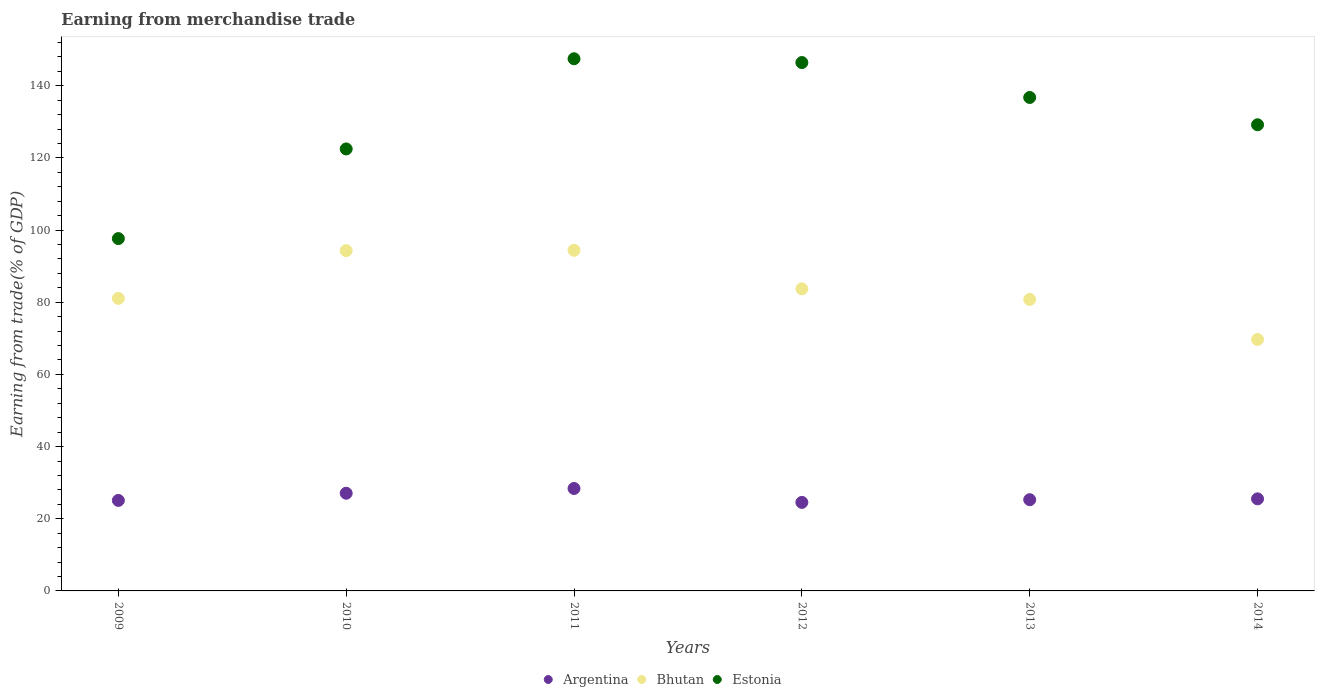How many different coloured dotlines are there?
Your answer should be compact. 3. What is the earnings from trade in Bhutan in 2012?
Ensure brevity in your answer.  83.71. Across all years, what is the maximum earnings from trade in Argentina?
Your answer should be very brief. 28.39. Across all years, what is the minimum earnings from trade in Argentina?
Keep it short and to the point. 24.53. In which year was the earnings from trade in Bhutan maximum?
Give a very brief answer. 2011. In which year was the earnings from trade in Argentina minimum?
Offer a very short reply. 2012. What is the total earnings from trade in Estonia in the graph?
Offer a terse response. 779.94. What is the difference between the earnings from trade in Bhutan in 2010 and that in 2014?
Ensure brevity in your answer.  24.62. What is the difference between the earnings from trade in Estonia in 2012 and the earnings from trade in Argentina in 2009?
Offer a terse response. 121.34. What is the average earnings from trade in Estonia per year?
Your answer should be very brief. 129.99. In the year 2014, what is the difference between the earnings from trade in Estonia and earnings from trade in Bhutan?
Provide a short and direct response. 59.5. In how many years, is the earnings from trade in Bhutan greater than 40 %?
Ensure brevity in your answer.  6. What is the ratio of the earnings from trade in Argentina in 2009 to that in 2013?
Your response must be concise. 0.99. Is the earnings from trade in Argentina in 2011 less than that in 2012?
Provide a short and direct response. No. What is the difference between the highest and the second highest earnings from trade in Estonia?
Provide a succinct answer. 1.05. What is the difference between the highest and the lowest earnings from trade in Bhutan?
Ensure brevity in your answer.  24.7. Is the sum of the earnings from trade in Bhutan in 2010 and 2012 greater than the maximum earnings from trade in Estonia across all years?
Give a very brief answer. Yes. What is the difference between two consecutive major ticks on the Y-axis?
Offer a very short reply. 20. Where does the legend appear in the graph?
Offer a terse response. Bottom center. How are the legend labels stacked?
Provide a short and direct response. Horizontal. What is the title of the graph?
Make the answer very short. Earning from merchandise trade. What is the label or title of the X-axis?
Make the answer very short. Years. What is the label or title of the Y-axis?
Give a very brief answer. Earning from trade(% of GDP). What is the Earning from trade(% of GDP) of Argentina in 2009?
Your answer should be compact. 25.08. What is the Earning from trade(% of GDP) in Bhutan in 2009?
Provide a succinct answer. 81.06. What is the Earning from trade(% of GDP) in Estonia in 2009?
Give a very brief answer. 97.64. What is the Earning from trade(% of GDP) of Argentina in 2010?
Offer a very short reply. 27.07. What is the Earning from trade(% of GDP) of Bhutan in 2010?
Your answer should be compact. 94.3. What is the Earning from trade(% of GDP) in Estonia in 2010?
Your answer should be very brief. 122.48. What is the Earning from trade(% of GDP) in Argentina in 2011?
Keep it short and to the point. 28.39. What is the Earning from trade(% of GDP) of Bhutan in 2011?
Your answer should be compact. 94.39. What is the Earning from trade(% of GDP) of Estonia in 2011?
Provide a succinct answer. 147.47. What is the Earning from trade(% of GDP) in Argentina in 2012?
Give a very brief answer. 24.53. What is the Earning from trade(% of GDP) of Bhutan in 2012?
Keep it short and to the point. 83.71. What is the Earning from trade(% of GDP) of Estonia in 2012?
Your answer should be compact. 146.42. What is the Earning from trade(% of GDP) in Argentina in 2013?
Give a very brief answer. 25.28. What is the Earning from trade(% of GDP) of Bhutan in 2013?
Keep it short and to the point. 80.78. What is the Earning from trade(% of GDP) in Estonia in 2013?
Provide a succinct answer. 136.74. What is the Earning from trade(% of GDP) in Argentina in 2014?
Your response must be concise. 25.52. What is the Earning from trade(% of GDP) of Bhutan in 2014?
Provide a succinct answer. 69.69. What is the Earning from trade(% of GDP) of Estonia in 2014?
Your answer should be very brief. 129.18. Across all years, what is the maximum Earning from trade(% of GDP) in Argentina?
Provide a succinct answer. 28.39. Across all years, what is the maximum Earning from trade(% of GDP) in Bhutan?
Offer a very short reply. 94.39. Across all years, what is the maximum Earning from trade(% of GDP) in Estonia?
Offer a terse response. 147.47. Across all years, what is the minimum Earning from trade(% of GDP) of Argentina?
Provide a succinct answer. 24.53. Across all years, what is the minimum Earning from trade(% of GDP) in Bhutan?
Offer a terse response. 69.69. Across all years, what is the minimum Earning from trade(% of GDP) in Estonia?
Your response must be concise. 97.64. What is the total Earning from trade(% of GDP) of Argentina in the graph?
Keep it short and to the point. 155.87. What is the total Earning from trade(% of GDP) in Bhutan in the graph?
Keep it short and to the point. 503.93. What is the total Earning from trade(% of GDP) of Estonia in the graph?
Provide a succinct answer. 779.94. What is the difference between the Earning from trade(% of GDP) of Argentina in 2009 and that in 2010?
Provide a short and direct response. -1.99. What is the difference between the Earning from trade(% of GDP) of Bhutan in 2009 and that in 2010?
Your answer should be compact. -13.24. What is the difference between the Earning from trade(% of GDP) in Estonia in 2009 and that in 2010?
Provide a succinct answer. -24.85. What is the difference between the Earning from trade(% of GDP) in Argentina in 2009 and that in 2011?
Give a very brief answer. -3.31. What is the difference between the Earning from trade(% of GDP) of Bhutan in 2009 and that in 2011?
Offer a terse response. -13.33. What is the difference between the Earning from trade(% of GDP) in Estonia in 2009 and that in 2011?
Provide a short and direct response. -49.84. What is the difference between the Earning from trade(% of GDP) in Argentina in 2009 and that in 2012?
Make the answer very short. 0.55. What is the difference between the Earning from trade(% of GDP) in Bhutan in 2009 and that in 2012?
Provide a short and direct response. -2.65. What is the difference between the Earning from trade(% of GDP) of Estonia in 2009 and that in 2012?
Ensure brevity in your answer.  -48.78. What is the difference between the Earning from trade(% of GDP) of Bhutan in 2009 and that in 2013?
Your answer should be compact. 0.28. What is the difference between the Earning from trade(% of GDP) in Estonia in 2009 and that in 2013?
Your response must be concise. -39.11. What is the difference between the Earning from trade(% of GDP) of Argentina in 2009 and that in 2014?
Keep it short and to the point. -0.44. What is the difference between the Earning from trade(% of GDP) in Bhutan in 2009 and that in 2014?
Ensure brevity in your answer.  11.38. What is the difference between the Earning from trade(% of GDP) of Estonia in 2009 and that in 2014?
Your answer should be very brief. -31.54. What is the difference between the Earning from trade(% of GDP) in Argentina in 2010 and that in 2011?
Your answer should be compact. -1.31. What is the difference between the Earning from trade(% of GDP) of Bhutan in 2010 and that in 2011?
Make the answer very short. -0.09. What is the difference between the Earning from trade(% of GDP) in Estonia in 2010 and that in 2011?
Provide a succinct answer. -24.99. What is the difference between the Earning from trade(% of GDP) in Argentina in 2010 and that in 2012?
Ensure brevity in your answer.  2.54. What is the difference between the Earning from trade(% of GDP) in Bhutan in 2010 and that in 2012?
Offer a terse response. 10.59. What is the difference between the Earning from trade(% of GDP) in Estonia in 2010 and that in 2012?
Provide a short and direct response. -23.94. What is the difference between the Earning from trade(% of GDP) of Argentina in 2010 and that in 2013?
Your response must be concise. 1.79. What is the difference between the Earning from trade(% of GDP) of Bhutan in 2010 and that in 2013?
Keep it short and to the point. 13.52. What is the difference between the Earning from trade(% of GDP) of Estonia in 2010 and that in 2013?
Your answer should be very brief. -14.26. What is the difference between the Earning from trade(% of GDP) of Argentina in 2010 and that in 2014?
Offer a very short reply. 1.56. What is the difference between the Earning from trade(% of GDP) in Bhutan in 2010 and that in 2014?
Make the answer very short. 24.62. What is the difference between the Earning from trade(% of GDP) of Estonia in 2010 and that in 2014?
Offer a very short reply. -6.7. What is the difference between the Earning from trade(% of GDP) in Argentina in 2011 and that in 2012?
Provide a short and direct response. 3.86. What is the difference between the Earning from trade(% of GDP) in Bhutan in 2011 and that in 2012?
Your answer should be compact. 10.68. What is the difference between the Earning from trade(% of GDP) in Estonia in 2011 and that in 2012?
Ensure brevity in your answer.  1.05. What is the difference between the Earning from trade(% of GDP) in Argentina in 2011 and that in 2013?
Ensure brevity in your answer.  3.11. What is the difference between the Earning from trade(% of GDP) in Bhutan in 2011 and that in 2013?
Give a very brief answer. 13.61. What is the difference between the Earning from trade(% of GDP) in Estonia in 2011 and that in 2013?
Give a very brief answer. 10.73. What is the difference between the Earning from trade(% of GDP) in Argentina in 2011 and that in 2014?
Ensure brevity in your answer.  2.87. What is the difference between the Earning from trade(% of GDP) of Bhutan in 2011 and that in 2014?
Ensure brevity in your answer.  24.7. What is the difference between the Earning from trade(% of GDP) of Estonia in 2011 and that in 2014?
Your response must be concise. 18.29. What is the difference between the Earning from trade(% of GDP) in Argentina in 2012 and that in 2013?
Keep it short and to the point. -0.75. What is the difference between the Earning from trade(% of GDP) of Bhutan in 2012 and that in 2013?
Ensure brevity in your answer.  2.93. What is the difference between the Earning from trade(% of GDP) in Estonia in 2012 and that in 2013?
Keep it short and to the point. 9.68. What is the difference between the Earning from trade(% of GDP) in Argentina in 2012 and that in 2014?
Offer a very short reply. -0.98. What is the difference between the Earning from trade(% of GDP) in Bhutan in 2012 and that in 2014?
Provide a short and direct response. 14.02. What is the difference between the Earning from trade(% of GDP) in Estonia in 2012 and that in 2014?
Your answer should be compact. 17.24. What is the difference between the Earning from trade(% of GDP) of Argentina in 2013 and that in 2014?
Keep it short and to the point. -0.24. What is the difference between the Earning from trade(% of GDP) in Bhutan in 2013 and that in 2014?
Ensure brevity in your answer.  11.1. What is the difference between the Earning from trade(% of GDP) of Estonia in 2013 and that in 2014?
Give a very brief answer. 7.56. What is the difference between the Earning from trade(% of GDP) of Argentina in 2009 and the Earning from trade(% of GDP) of Bhutan in 2010?
Your answer should be very brief. -69.22. What is the difference between the Earning from trade(% of GDP) in Argentina in 2009 and the Earning from trade(% of GDP) in Estonia in 2010?
Make the answer very short. -97.4. What is the difference between the Earning from trade(% of GDP) of Bhutan in 2009 and the Earning from trade(% of GDP) of Estonia in 2010?
Your answer should be compact. -41.42. What is the difference between the Earning from trade(% of GDP) in Argentina in 2009 and the Earning from trade(% of GDP) in Bhutan in 2011?
Offer a terse response. -69.31. What is the difference between the Earning from trade(% of GDP) of Argentina in 2009 and the Earning from trade(% of GDP) of Estonia in 2011?
Your answer should be very brief. -122.4. What is the difference between the Earning from trade(% of GDP) in Bhutan in 2009 and the Earning from trade(% of GDP) in Estonia in 2011?
Your answer should be compact. -66.41. What is the difference between the Earning from trade(% of GDP) of Argentina in 2009 and the Earning from trade(% of GDP) of Bhutan in 2012?
Provide a short and direct response. -58.63. What is the difference between the Earning from trade(% of GDP) in Argentina in 2009 and the Earning from trade(% of GDP) in Estonia in 2012?
Offer a terse response. -121.34. What is the difference between the Earning from trade(% of GDP) in Bhutan in 2009 and the Earning from trade(% of GDP) in Estonia in 2012?
Give a very brief answer. -65.36. What is the difference between the Earning from trade(% of GDP) of Argentina in 2009 and the Earning from trade(% of GDP) of Bhutan in 2013?
Provide a succinct answer. -55.7. What is the difference between the Earning from trade(% of GDP) in Argentina in 2009 and the Earning from trade(% of GDP) in Estonia in 2013?
Your answer should be very brief. -111.66. What is the difference between the Earning from trade(% of GDP) in Bhutan in 2009 and the Earning from trade(% of GDP) in Estonia in 2013?
Your answer should be compact. -55.68. What is the difference between the Earning from trade(% of GDP) in Argentina in 2009 and the Earning from trade(% of GDP) in Bhutan in 2014?
Provide a short and direct response. -44.61. What is the difference between the Earning from trade(% of GDP) of Argentina in 2009 and the Earning from trade(% of GDP) of Estonia in 2014?
Keep it short and to the point. -104.1. What is the difference between the Earning from trade(% of GDP) in Bhutan in 2009 and the Earning from trade(% of GDP) in Estonia in 2014?
Your answer should be compact. -48.12. What is the difference between the Earning from trade(% of GDP) in Argentina in 2010 and the Earning from trade(% of GDP) in Bhutan in 2011?
Offer a terse response. -67.32. What is the difference between the Earning from trade(% of GDP) of Argentina in 2010 and the Earning from trade(% of GDP) of Estonia in 2011?
Make the answer very short. -120.4. What is the difference between the Earning from trade(% of GDP) of Bhutan in 2010 and the Earning from trade(% of GDP) of Estonia in 2011?
Keep it short and to the point. -53.17. What is the difference between the Earning from trade(% of GDP) of Argentina in 2010 and the Earning from trade(% of GDP) of Bhutan in 2012?
Your response must be concise. -56.64. What is the difference between the Earning from trade(% of GDP) in Argentina in 2010 and the Earning from trade(% of GDP) in Estonia in 2012?
Provide a short and direct response. -119.35. What is the difference between the Earning from trade(% of GDP) of Bhutan in 2010 and the Earning from trade(% of GDP) of Estonia in 2012?
Offer a terse response. -52.12. What is the difference between the Earning from trade(% of GDP) of Argentina in 2010 and the Earning from trade(% of GDP) of Bhutan in 2013?
Provide a short and direct response. -53.71. What is the difference between the Earning from trade(% of GDP) in Argentina in 2010 and the Earning from trade(% of GDP) in Estonia in 2013?
Offer a very short reply. -109.67. What is the difference between the Earning from trade(% of GDP) of Bhutan in 2010 and the Earning from trade(% of GDP) of Estonia in 2013?
Provide a succinct answer. -42.44. What is the difference between the Earning from trade(% of GDP) of Argentina in 2010 and the Earning from trade(% of GDP) of Bhutan in 2014?
Give a very brief answer. -42.61. What is the difference between the Earning from trade(% of GDP) of Argentina in 2010 and the Earning from trade(% of GDP) of Estonia in 2014?
Offer a terse response. -102.11. What is the difference between the Earning from trade(% of GDP) of Bhutan in 2010 and the Earning from trade(% of GDP) of Estonia in 2014?
Your response must be concise. -34.88. What is the difference between the Earning from trade(% of GDP) in Argentina in 2011 and the Earning from trade(% of GDP) in Bhutan in 2012?
Your answer should be compact. -55.32. What is the difference between the Earning from trade(% of GDP) in Argentina in 2011 and the Earning from trade(% of GDP) in Estonia in 2012?
Provide a short and direct response. -118.03. What is the difference between the Earning from trade(% of GDP) of Bhutan in 2011 and the Earning from trade(% of GDP) of Estonia in 2012?
Provide a short and direct response. -52.03. What is the difference between the Earning from trade(% of GDP) in Argentina in 2011 and the Earning from trade(% of GDP) in Bhutan in 2013?
Your answer should be very brief. -52.39. What is the difference between the Earning from trade(% of GDP) of Argentina in 2011 and the Earning from trade(% of GDP) of Estonia in 2013?
Offer a terse response. -108.36. What is the difference between the Earning from trade(% of GDP) in Bhutan in 2011 and the Earning from trade(% of GDP) in Estonia in 2013?
Your response must be concise. -42.36. What is the difference between the Earning from trade(% of GDP) in Argentina in 2011 and the Earning from trade(% of GDP) in Bhutan in 2014?
Make the answer very short. -41.3. What is the difference between the Earning from trade(% of GDP) of Argentina in 2011 and the Earning from trade(% of GDP) of Estonia in 2014?
Make the answer very short. -100.79. What is the difference between the Earning from trade(% of GDP) in Bhutan in 2011 and the Earning from trade(% of GDP) in Estonia in 2014?
Ensure brevity in your answer.  -34.79. What is the difference between the Earning from trade(% of GDP) of Argentina in 2012 and the Earning from trade(% of GDP) of Bhutan in 2013?
Make the answer very short. -56.25. What is the difference between the Earning from trade(% of GDP) in Argentina in 2012 and the Earning from trade(% of GDP) in Estonia in 2013?
Keep it short and to the point. -112.21. What is the difference between the Earning from trade(% of GDP) in Bhutan in 2012 and the Earning from trade(% of GDP) in Estonia in 2013?
Keep it short and to the point. -53.03. What is the difference between the Earning from trade(% of GDP) in Argentina in 2012 and the Earning from trade(% of GDP) in Bhutan in 2014?
Your response must be concise. -45.15. What is the difference between the Earning from trade(% of GDP) of Argentina in 2012 and the Earning from trade(% of GDP) of Estonia in 2014?
Your answer should be very brief. -104.65. What is the difference between the Earning from trade(% of GDP) of Bhutan in 2012 and the Earning from trade(% of GDP) of Estonia in 2014?
Your answer should be compact. -45.47. What is the difference between the Earning from trade(% of GDP) in Argentina in 2013 and the Earning from trade(% of GDP) in Bhutan in 2014?
Your answer should be very brief. -44.41. What is the difference between the Earning from trade(% of GDP) of Argentina in 2013 and the Earning from trade(% of GDP) of Estonia in 2014?
Your answer should be very brief. -103.9. What is the difference between the Earning from trade(% of GDP) in Bhutan in 2013 and the Earning from trade(% of GDP) in Estonia in 2014?
Your answer should be very brief. -48.4. What is the average Earning from trade(% of GDP) in Argentina per year?
Ensure brevity in your answer.  25.98. What is the average Earning from trade(% of GDP) of Bhutan per year?
Offer a terse response. 83.99. What is the average Earning from trade(% of GDP) of Estonia per year?
Provide a short and direct response. 129.99. In the year 2009, what is the difference between the Earning from trade(% of GDP) in Argentina and Earning from trade(% of GDP) in Bhutan?
Your answer should be compact. -55.98. In the year 2009, what is the difference between the Earning from trade(% of GDP) of Argentina and Earning from trade(% of GDP) of Estonia?
Offer a terse response. -72.56. In the year 2009, what is the difference between the Earning from trade(% of GDP) of Bhutan and Earning from trade(% of GDP) of Estonia?
Your answer should be very brief. -16.57. In the year 2010, what is the difference between the Earning from trade(% of GDP) in Argentina and Earning from trade(% of GDP) in Bhutan?
Make the answer very short. -67.23. In the year 2010, what is the difference between the Earning from trade(% of GDP) in Argentina and Earning from trade(% of GDP) in Estonia?
Your response must be concise. -95.41. In the year 2010, what is the difference between the Earning from trade(% of GDP) of Bhutan and Earning from trade(% of GDP) of Estonia?
Provide a short and direct response. -28.18. In the year 2011, what is the difference between the Earning from trade(% of GDP) of Argentina and Earning from trade(% of GDP) of Bhutan?
Your answer should be compact. -66. In the year 2011, what is the difference between the Earning from trade(% of GDP) in Argentina and Earning from trade(% of GDP) in Estonia?
Offer a very short reply. -119.09. In the year 2011, what is the difference between the Earning from trade(% of GDP) in Bhutan and Earning from trade(% of GDP) in Estonia?
Offer a very short reply. -53.09. In the year 2012, what is the difference between the Earning from trade(% of GDP) of Argentina and Earning from trade(% of GDP) of Bhutan?
Offer a terse response. -59.18. In the year 2012, what is the difference between the Earning from trade(% of GDP) of Argentina and Earning from trade(% of GDP) of Estonia?
Offer a terse response. -121.89. In the year 2012, what is the difference between the Earning from trade(% of GDP) in Bhutan and Earning from trade(% of GDP) in Estonia?
Offer a very short reply. -62.71. In the year 2013, what is the difference between the Earning from trade(% of GDP) in Argentina and Earning from trade(% of GDP) in Bhutan?
Offer a very short reply. -55.5. In the year 2013, what is the difference between the Earning from trade(% of GDP) in Argentina and Earning from trade(% of GDP) in Estonia?
Your answer should be very brief. -111.46. In the year 2013, what is the difference between the Earning from trade(% of GDP) in Bhutan and Earning from trade(% of GDP) in Estonia?
Keep it short and to the point. -55.96. In the year 2014, what is the difference between the Earning from trade(% of GDP) in Argentina and Earning from trade(% of GDP) in Bhutan?
Ensure brevity in your answer.  -44.17. In the year 2014, what is the difference between the Earning from trade(% of GDP) of Argentina and Earning from trade(% of GDP) of Estonia?
Offer a very short reply. -103.67. In the year 2014, what is the difference between the Earning from trade(% of GDP) of Bhutan and Earning from trade(% of GDP) of Estonia?
Provide a short and direct response. -59.5. What is the ratio of the Earning from trade(% of GDP) of Argentina in 2009 to that in 2010?
Your response must be concise. 0.93. What is the ratio of the Earning from trade(% of GDP) of Bhutan in 2009 to that in 2010?
Keep it short and to the point. 0.86. What is the ratio of the Earning from trade(% of GDP) in Estonia in 2009 to that in 2010?
Provide a short and direct response. 0.8. What is the ratio of the Earning from trade(% of GDP) of Argentina in 2009 to that in 2011?
Ensure brevity in your answer.  0.88. What is the ratio of the Earning from trade(% of GDP) of Bhutan in 2009 to that in 2011?
Make the answer very short. 0.86. What is the ratio of the Earning from trade(% of GDP) in Estonia in 2009 to that in 2011?
Offer a terse response. 0.66. What is the ratio of the Earning from trade(% of GDP) of Argentina in 2009 to that in 2012?
Your response must be concise. 1.02. What is the ratio of the Earning from trade(% of GDP) of Bhutan in 2009 to that in 2012?
Keep it short and to the point. 0.97. What is the ratio of the Earning from trade(% of GDP) in Estonia in 2009 to that in 2012?
Keep it short and to the point. 0.67. What is the ratio of the Earning from trade(% of GDP) in Argentina in 2009 to that in 2013?
Your response must be concise. 0.99. What is the ratio of the Earning from trade(% of GDP) of Bhutan in 2009 to that in 2013?
Ensure brevity in your answer.  1. What is the ratio of the Earning from trade(% of GDP) in Estonia in 2009 to that in 2013?
Make the answer very short. 0.71. What is the ratio of the Earning from trade(% of GDP) of Argentina in 2009 to that in 2014?
Make the answer very short. 0.98. What is the ratio of the Earning from trade(% of GDP) in Bhutan in 2009 to that in 2014?
Make the answer very short. 1.16. What is the ratio of the Earning from trade(% of GDP) in Estonia in 2009 to that in 2014?
Make the answer very short. 0.76. What is the ratio of the Earning from trade(% of GDP) in Argentina in 2010 to that in 2011?
Your answer should be compact. 0.95. What is the ratio of the Earning from trade(% of GDP) of Estonia in 2010 to that in 2011?
Ensure brevity in your answer.  0.83. What is the ratio of the Earning from trade(% of GDP) of Argentina in 2010 to that in 2012?
Provide a succinct answer. 1.1. What is the ratio of the Earning from trade(% of GDP) in Bhutan in 2010 to that in 2012?
Keep it short and to the point. 1.13. What is the ratio of the Earning from trade(% of GDP) in Estonia in 2010 to that in 2012?
Make the answer very short. 0.84. What is the ratio of the Earning from trade(% of GDP) of Argentina in 2010 to that in 2013?
Your answer should be very brief. 1.07. What is the ratio of the Earning from trade(% of GDP) of Bhutan in 2010 to that in 2013?
Keep it short and to the point. 1.17. What is the ratio of the Earning from trade(% of GDP) in Estonia in 2010 to that in 2013?
Offer a very short reply. 0.9. What is the ratio of the Earning from trade(% of GDP) of Argentina in 2010 to that in 2014?
Give a very brief answer. 1.06. What is the ratio of the Earning from trade(% of GDP) of Bhutan in 2010 to that in 2014?
Make the answer very short. 1.35. What is the ratio of the Earning from trade(% of GDP) in Estonia in 2010 to that in 2014?
Make the answer very short. 0.95. What is the ratio of the Earning from trade(% of GDP) in Argentina in 2011 to that in 2012?
Your answer should be compact. 1.16. What is the ratio of the Earning from trade(% of GDP) in Bhutan in 2011 to that in 2012?
Offer a terse response. 1.13. What is the ratio of the Earning from trade(% of GDP) in Argentina in 2011 to that in 2013?
Ensure brevity in your answer.  1.12. What is the ratio of the Earning from trade(% of GDP) in Bhutan in 2011 to that in 2013?
Your response must be concise. 1.17. What is the ratio of the Earning from trade(% of GDP) in Estonia in 2011 to that in 2013?
Ensure brevity in your answer.  1.08. What is the ratio of the Earning from trade(% of GDP) in Argentina in 2011 to that in 2014?
Provide a succinct answer. 1.11. What is the ratio of the Earning from trade(% of GDP) of Bhutan in 2011 to that in 2014?
Give a very brief answer. 1.35. What is the ratio of the Earning from trade(% of GDP) in Estonia in 2011 to that in 2014?
Offer a very short reply. 1.14. What is the ratio of the Earning from trade(% of GDP) of Argentina in 2012 to that in 2013?
Give a very brief answer. 0.97. What is the ratio of the Earning from trade(% of GDP) in Bhutan in 2012 to that in 2013?
Give a very brief answer. 1.04. What is the ratio of the Earning from trade(% of GDP) in Estonia in 2012 to that in 2013?
Your answer should be compact. 1.07. What is the ratio of the Earning from trade(% of GDP) of Argentina in 2012 to that in 2014?
Provide a succinct answer. 0.96. What is the ratio of the Earning from trade(% of GDP) in Bhutan in 2012 to that in 2014?
Provide a short and direct response. 1.2. What is the ratio of the Earning from trade(% of GDP) of Estonia in 2012 to that in 2014?
Provide a short and direct response. 1.13. What is the ratio of the Earning from trade(% of GDP) in Bhutan in 2013 to that in 2014?
Your response must be concise. 1.16. What is the ratio of the Earning from trade(% of GDP) in Estonia in 2013 to that in 2014?
Ensure brevity in your answer.  1.06. What is the difference between the highest and the second highest Earning from trade(% of GDP) of Argentina?
Offer a terse response. 1.31. What is the difference between the highest and the second highest Earning from trade(% of GDP) of Bhutan?
Give a very brief answer. 0.09. What is the difference between the highest and the second highest Earning from trade(% of GDP) of Estonia?
Keep it short and to the point. 1.05. What is the difference between the highest and the lowest Earning from trade(% of GDP) of Argentina?
Keep it short and to the point. 3.86. What is the difference between the highest and the lowest Earning from trade(% of GDP) in Bhutan?
Give a very brief answer. 24.7. What is the difference between the highest and the lowest Earning from trade(% of GDP) in Estonia?
Offer a very short reply. 49.84. 